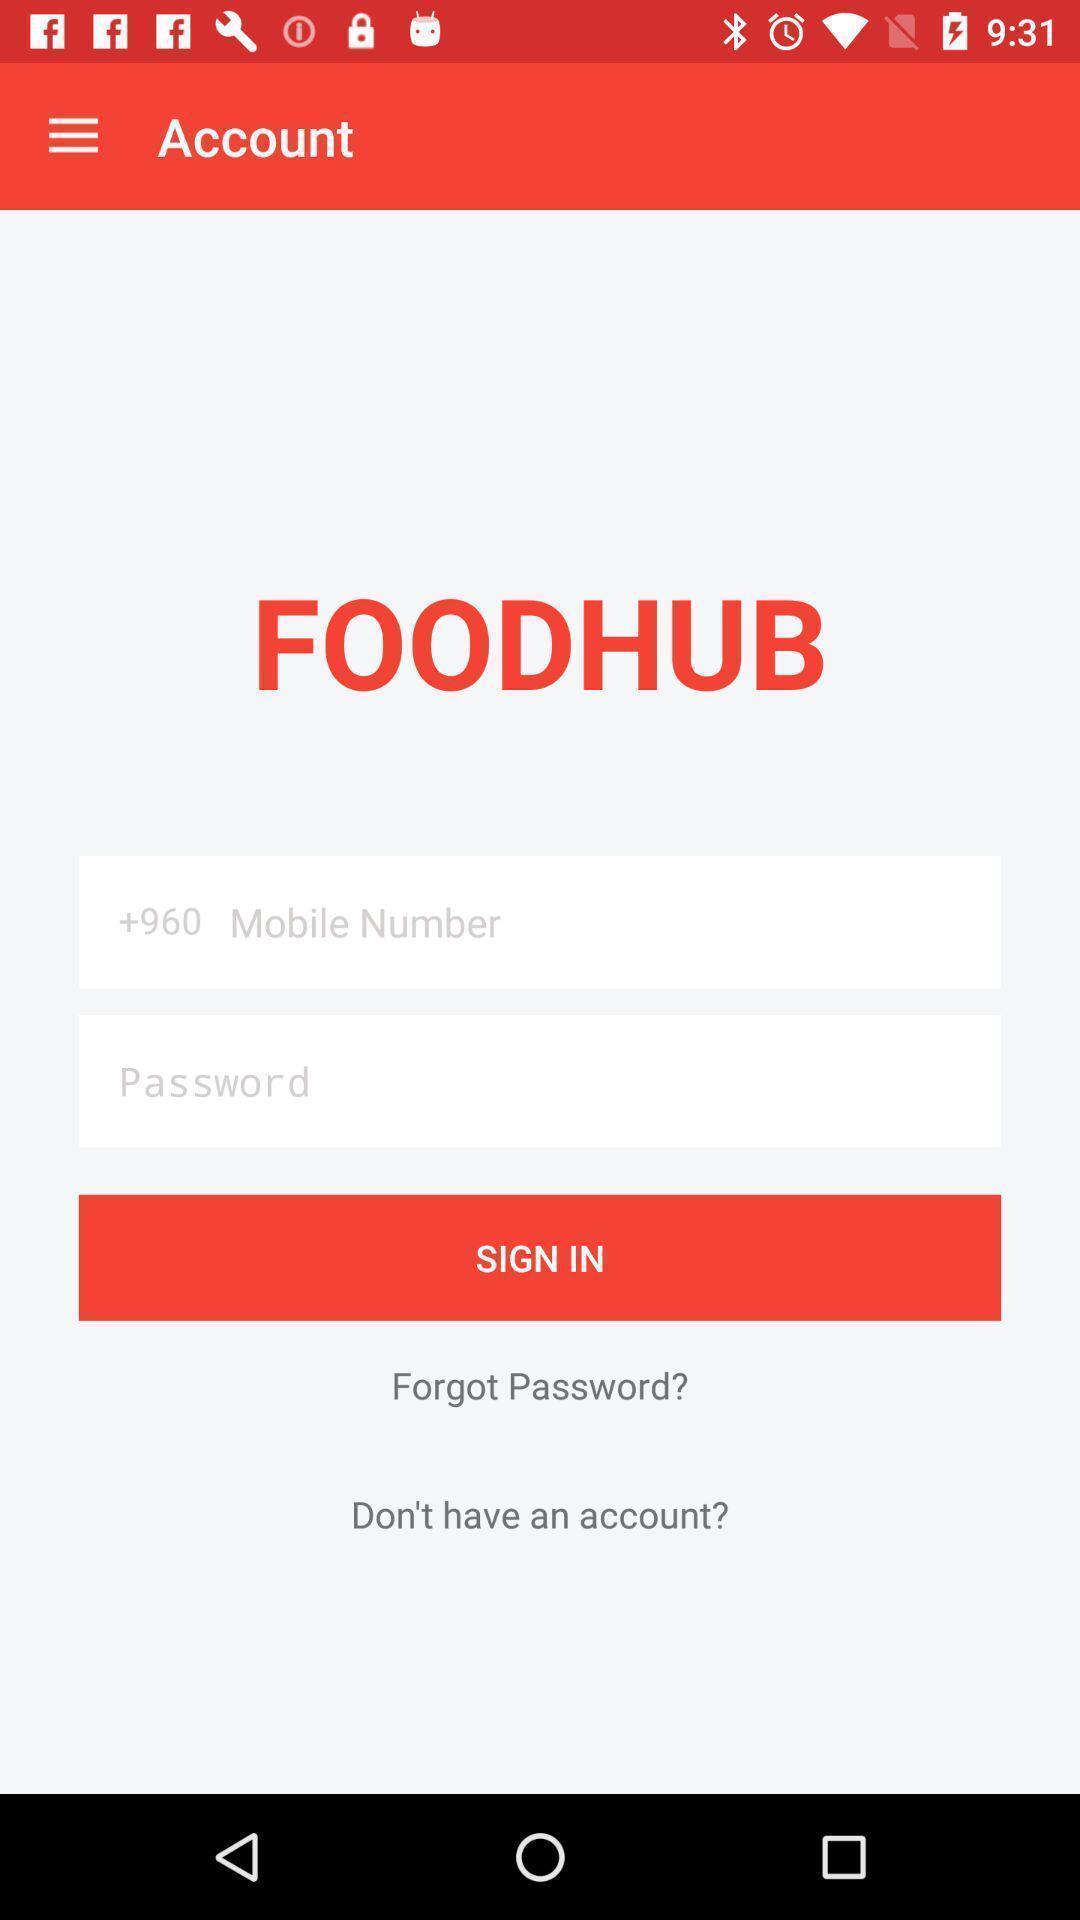Describe the visual elements of this screenshot. Sign up page of a food app. 